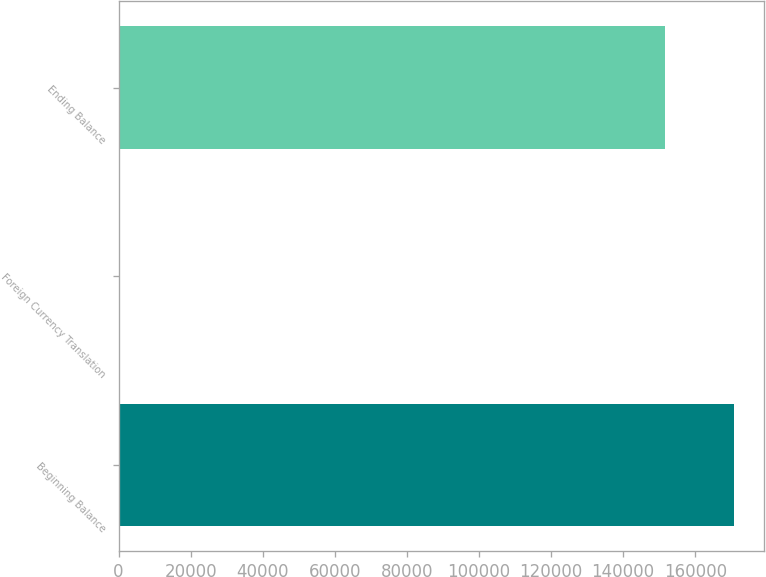Convert chart to OTSL. <chart><loc_0><loc_0><loc_500><loc_500><bar_chart><fcel>Beginning Balance<fcel>Foreign Currency Translation<fcel>Ending Balance<nl><fcel>170663<fcel>84<fcel>151512<nl></chart> 